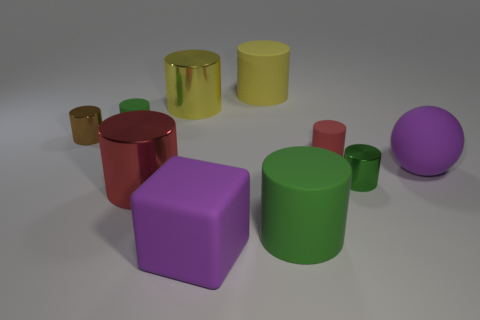Is there a small metallic thing left of the cylinder behind the big yellow metal cylinder?
Give a very brief answer. Yes. There is another big matte object that is the same shape as the yellow matte object; what is its color?
Ensure brevity in your answer.  Green. What color is the block that is made of the same material as the big purple sphere?
Ensure brevity in your answer.  Purple. There is a ball that is right of the green rubber thing left of the big rubber block; is there a green matte cylinder that is in front of it?
Keep it short and to the point. Yes. Are there fewer things behind the small green matte thing than objects behind the large matte cube?
Offer a terse response. Yes. How many small red things have the same material as the purple block?
Offer a terse response. 1. Is the size of the brown metallic object the same as the yellow cylinder that is right of the yellow shiny object?
Your response must be concise. No. What material is the sphere that is the same color as the big block?
Provide a succinct answer. Rubber. There is a purple matte object that is on the left side of the large matte cylinder that is to the right of the yellow rubber object that is on the right side of the red shiny cylinder; what size is it?
Your answer should be very brief. Large. Are there more big red things to the right of the green metal cylinder than cylinders left of the large green rubber cylinder?
Keep it short and to the point. No. 